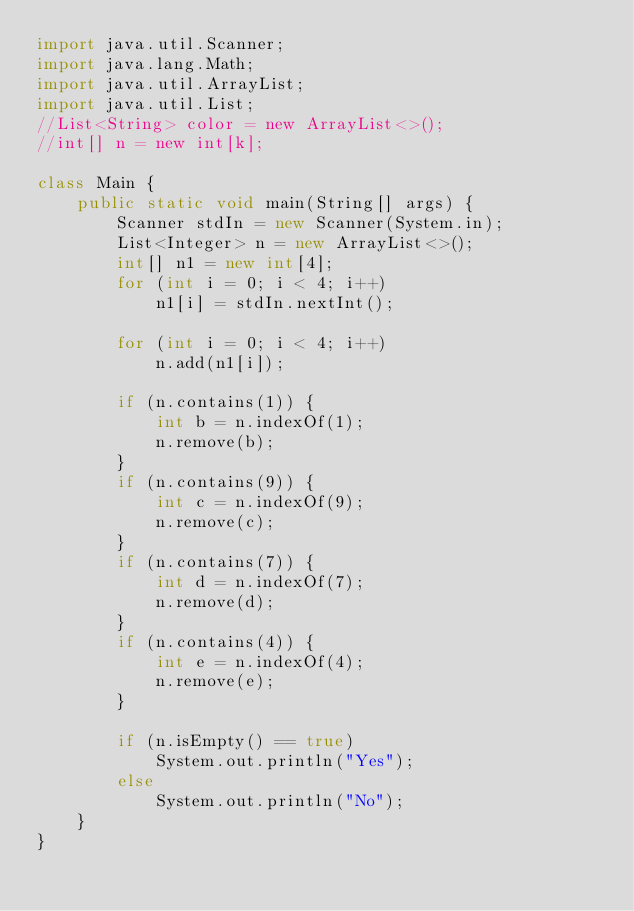Convert code to text. <code><loc_0><loc_0><loc_500><loc_500><_Java_>import java.util.Scanner;
import java.lang.Math;
import java.util.ArrayList;
import java.util.List;
//List<String> color = new ArrayList<>();
//int[] n = new int[k];

class Main {
	public static void main(String[] args) {
		Scanner stdIn = new Scanner(System.in);
		List<Integer> n = new ArrayList<>();
		int[] n1 = new int[4];
		for (int i = 0; i < 4; i++)
			n1[i] = stdIn.nextInt();
			
		for (int i = 0; i < 4; i++)
			n.add(n1[i]);

		if (n.contains(1)) {
			int b = n.indexOf(1);
			n.remove(b); 
		}
		if (n.contains(9)) {
			int c = n.indexOf(9);
			n.remove(c); 
		}
		if (n.contains(7)) {
			int d = n.indexOf(7);
			n.remove(d); 
		}
		if (n.contains(4)) {
			int e = n.indexOf(4);
			n.remove(e); 
		}

		if (n.isEmpty() == true) 
			System.out.println("Yes");
		else
			System.out.println("No");
	}
}</code> 